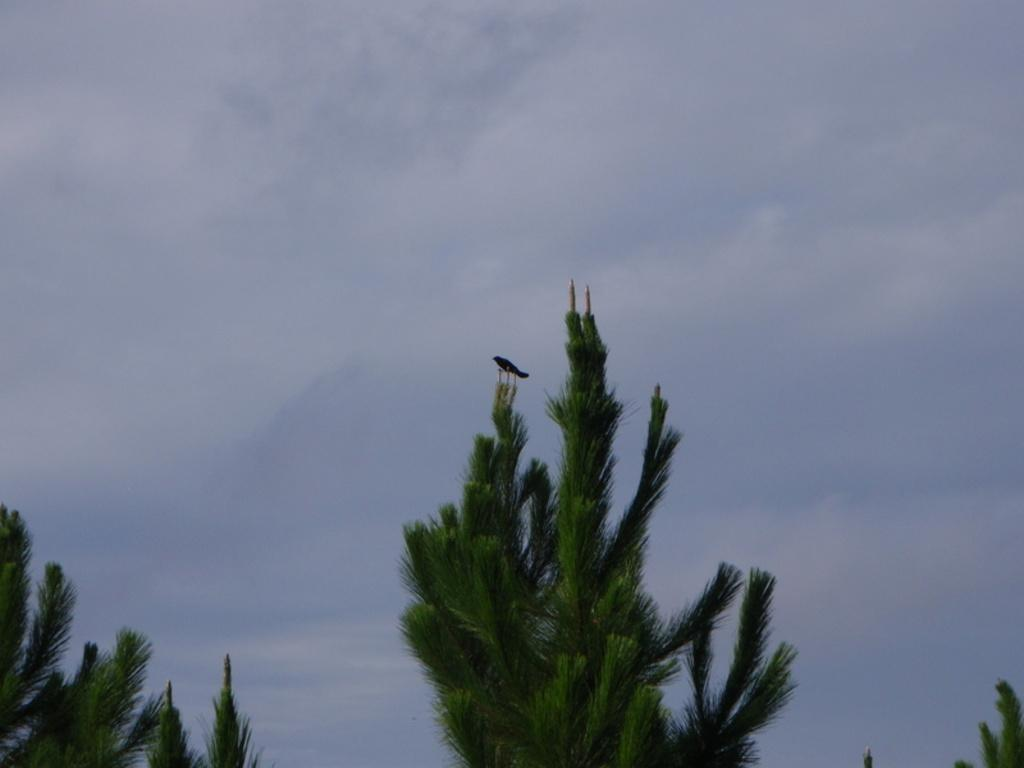What type of animal can be seen in the image? There is a bird in the image. Where is the bird located? The bird is on a tree. What can be seen in the background of the image? The sky is visible in the image. What type of vegetation is present in the image? There are trees with branches and leaves in the image. What type of passenger is the bird carrying in the image? There is no passenger present in the image; the bird is on a tree. How does the bird shake the tree in the image? The bird does not shake the tree in the image; it is simply perched on a branch. 